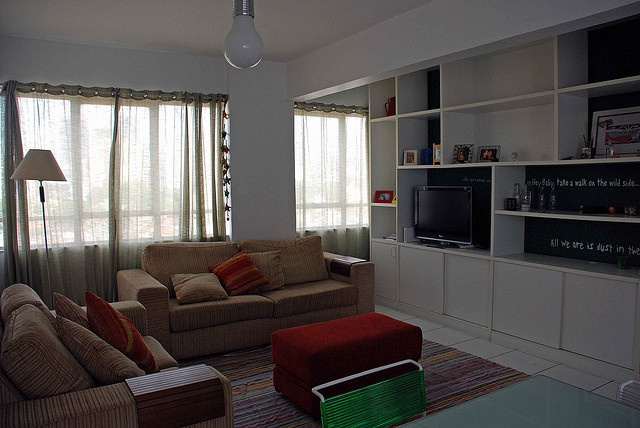Describe the objects in this image and their specific colors. I can see couch in gray and black tones, chair in gray and black tones, couch in gray, black, and maroon tones, dining table in gray, purple, darkblue, and black tones, and chair in gray, black, and darkgreen tones in this image. 